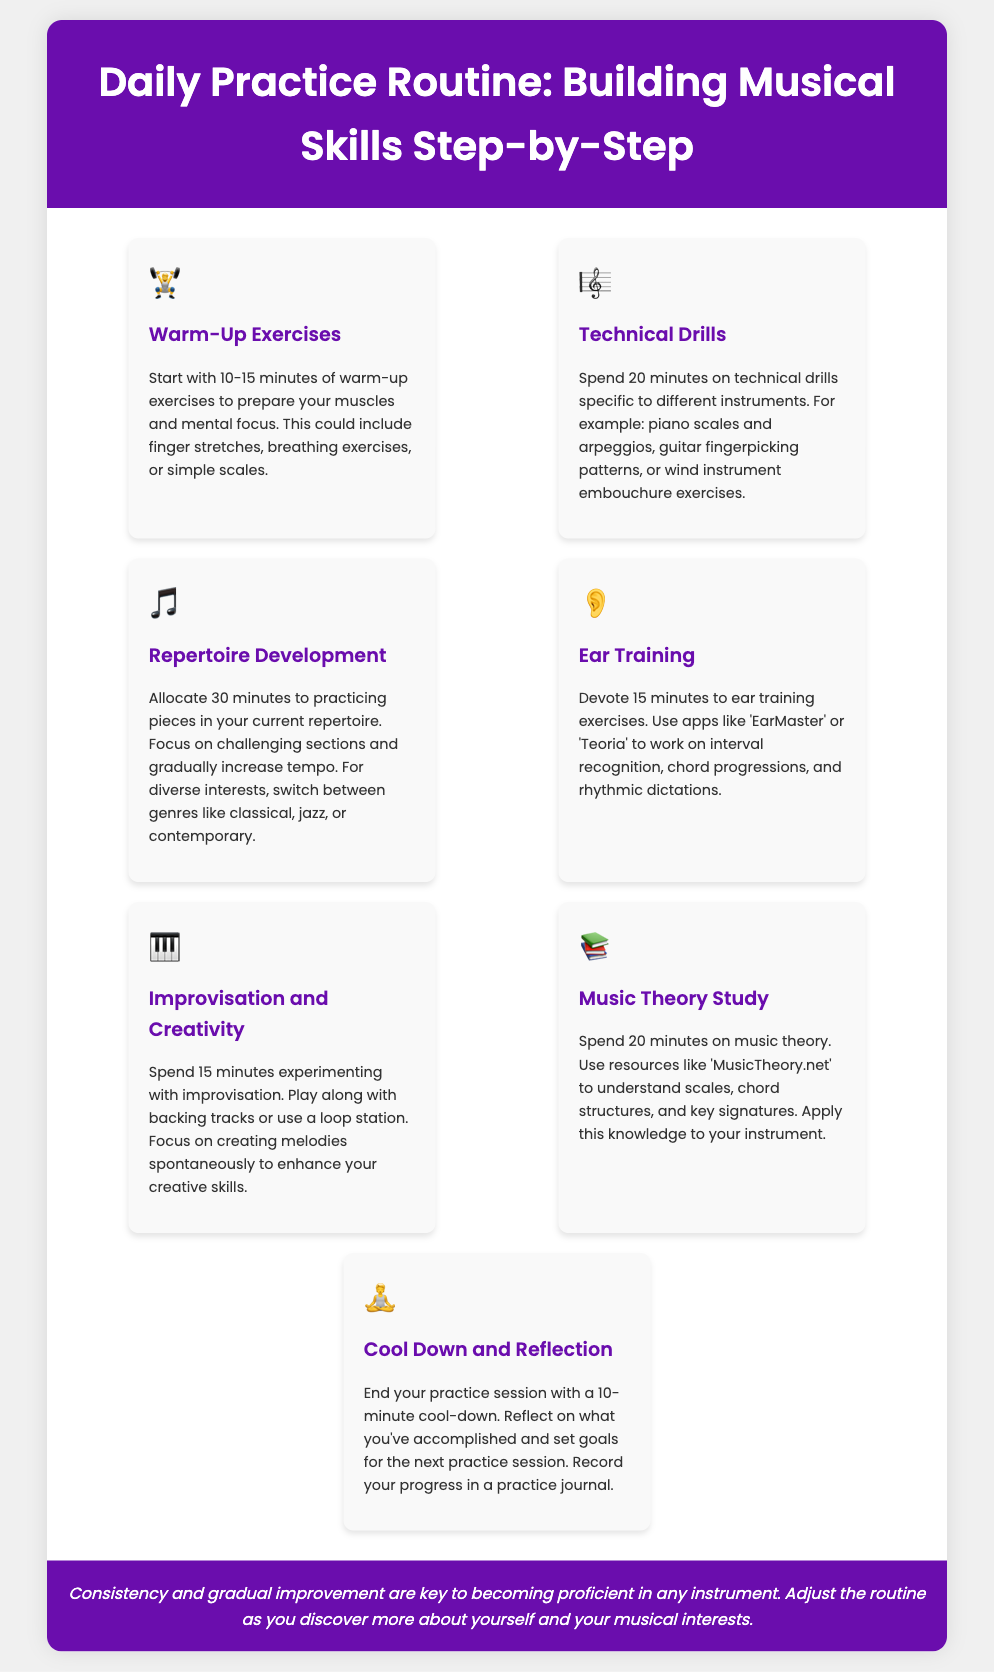What is the first step of the practice routine? The first step is Warm-Up Exercises, which prepares your muscles and mental focus.
Answer: Warm-Up Exercises How long should you spend on Technical Drills? The document specifies to spend 20 minutes on Technical Drills.
Answer: 20 minutes What icon represents Improvisation and Creativity? The document uses a keyboard icon (🎹) for Improvisation and Creativity.
Answer: 🎹 What is one resource mentioned for Music Theory Study? The document mentions 'MusicTheory.net' as a resource for studying music theory.
Answer: MusicTheory.net How much time is allocated for Ear Training? The time dedicated to Ear Training according to the document is 15 minutes.
Answer: 15 minutes What is the purpose of the Cool Down and Reflection step? The Cool Down and Reflection step is to reflect on accomplishments and set goals for the next session.
Answer: Reflect on accomplishments and set goals Which step involves using apps for interval recognition? The step that involves apps for interval recognition is Ear Training.
Answer: Ear Training What does the footer emphasize about musical practice? The footer emphasizes that consistency and gradual improvement are key to becoming proficient.
Answer: Consistency and gradual improvement How long is the practice session suggested for Repertoire Development? The practice session for Repertoire Development is suggested to be 30 minutes long.
Answer: 30 minutes 